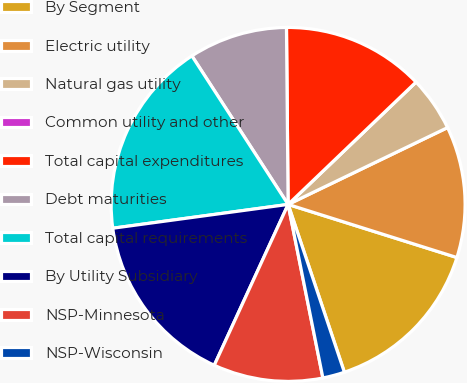<chart> <loc_0><loc_0><loc_500><loc_500><pie_chart><fcel>By Segment<fcel>Electric utility<fcel>Natural gas utility<fcel>Common utility and other<fcel>Total capital expenditures<fcel>Debt maturities<fcel>Total capital requirements<fcel>By Utility Subsidiary<fcel>NSP-Minnesota<fcel>NSP-Wisconsin<nl><fcel>15.0%<fcel>12.0%<fcel>5.0%<fcel>0.0%<fcel>13.0%<fcel>9.0%<fcel>18.0%<fcel>16.0%<fcel>10.0%<fcel>2.0%<nl></chart> 